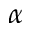Convert formula to latex. <formula><loc_0><loc_0><loc_500><loc_500>\alpha</formula> 